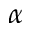Convert formula to latex. <formula><loc_0><loc_0><loc_500><loc_500>\alpha</formula> 